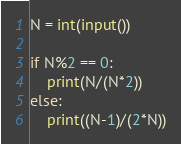<code> <loc_0><loc_0><loc_500><loc_500><_Python_>N = int(input())

if N%2 == 0:
    print(N/(N*2))
else:
    print((N-1)/(2*N))</code> 